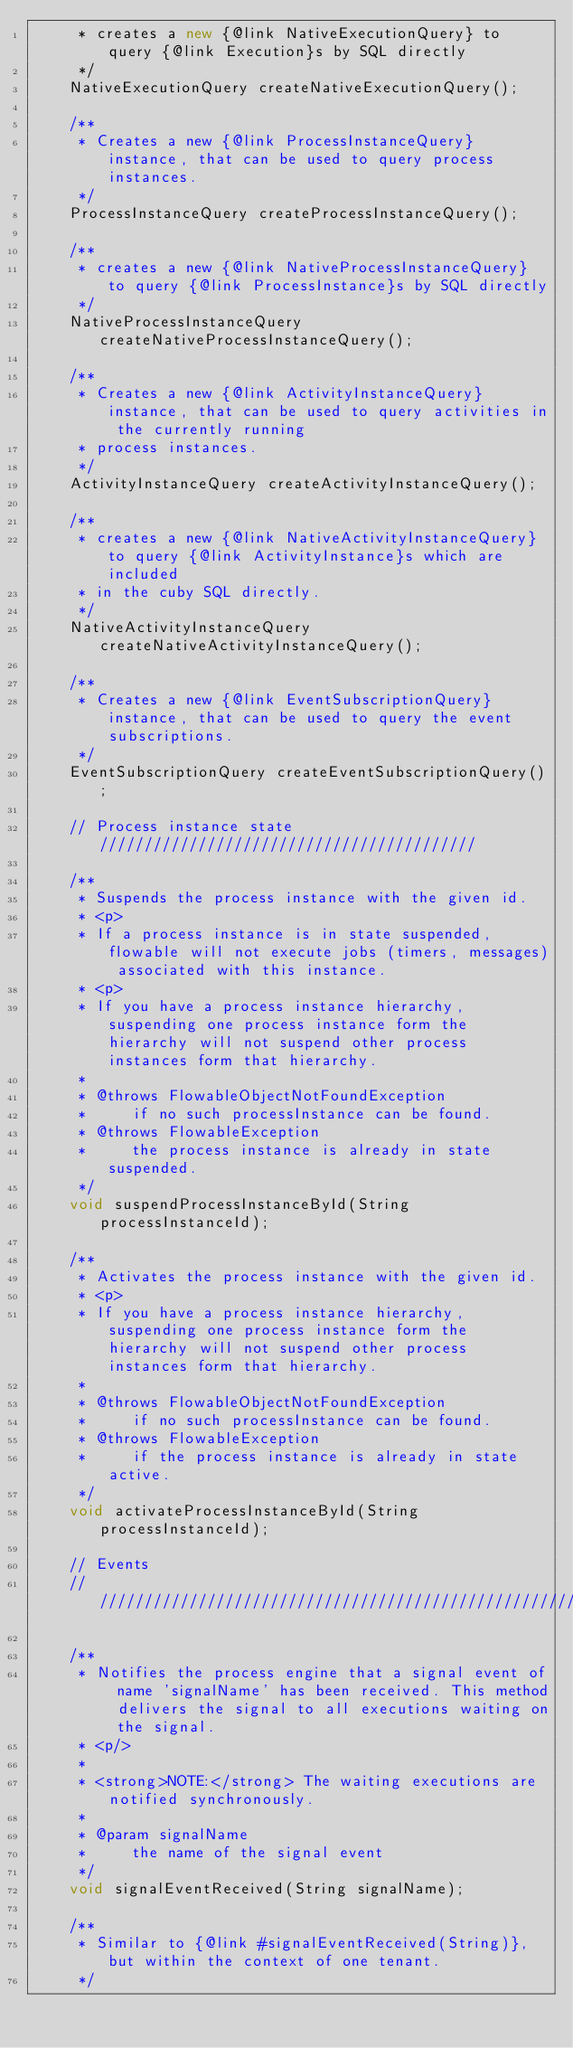Convert code to text. <code><loc_0><loc_0><loc_500><loc_500><_Java_>     * creates a new {@link NativeExecutionQuery} to query {@link Execution}s by SQL directly
     */
    NativeExecutionQuery createNativeExecutionQuery();

    /**
     * Creates a new {@link ProcessInstanceQuery} instance, that can be used to query process instances.
     */
    ProcessInstanceQuery createProcessInstanceQuery();

    /**
     * creates a new {@link NativeProcessInstanceQuery} to query {@link ProcessInstance}s by SQL directly
     */
    NativeProcessInstanceQuery createNativeProcessInstanceQuery();

    /**
     * Creates a new {@link ActivityInstanceQuery} instance, that can be used to query activities in the currently running
     * process instances.
     */
    ActivityInstanceQuery createActivityInstanceQuery();

    /**
     * creates a new {@link NativeActivityInstanceQuery} to query {@link ActivityInstance}s which are included
     * in the cuby SQL directly.
     */
    NativeActivityInstanceQuery createNativeActivityInstanceQuery();

    /**
     * Creates a new {@link EventSubscriptionQuery} instance, that can be used to query the event subscriptions.
     */
    EventSubscriptionQuery createEventSubscriptionQuery();

    // Process instance state //////////////////////////////////////////

    /**
     * Suspends the process instance with the given id.
     * <p>
     * If a process instance is in state suspended, flowable will not execute jobs (timers, messages) associated with this instance.
     * <p>
     * If you have a process instance hierarchy, suspending one process instance form the hierarchy will not suspend other process instances form that hierarchy.
     *
     * @throws FlowableObjectNotFoundException
     *     if no such processInstance can be found.
     * @throws FlowableException
     *     the process instance is already in state suspended.
     */
    void suspendProcessInstanceById(String processInstanceId);

    /**
     * Activates the process instance with the given id.
     * <p>
     * If you have a process instance hierarchy, suspending one process instance form the hierarchy will not suspend other process instances form that hierarchy.
     *
     * @throws FlowableObjectNotFoundException
     *     if no such processInstance can be found.
     * @throws FlowableException
     *     if the process instance is already in state active.
     */
    void activateProcessInstanceById(String processInstanceId);

    // Events
    // ////////////////////////////////////////////////////////////////////////

    /**
     * Notifies the process engine that a signal event of name 'signalName' has been received. This method delivers the signal to all executions waiting on the signal.
     * <p/>
     *
     * <strong>NOTE:</strong> The waiting executions are notified synchronously.
     *
     * @param signalName
     *     the name of the signal event
     */
    void signalEventReceived(String signalName);

    /**
     * Similar to {@link #signalEventReceived(String)}, but within the context of one tenant.
     */</code> 